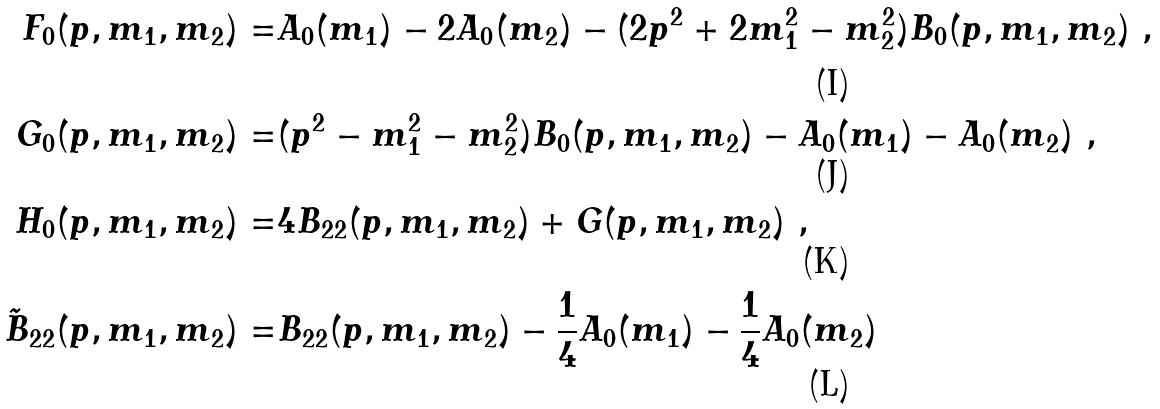Convert formula to latex. <formula><loc_0><loc_0><loc_500><loc_500>F _ { 0 } ( p , m _ { 1 } , m _ { 2 } ) = & A _ { 0 } ( m _ { 1 } ) - 2 A _ { 0 } ( m _ { 2 } ) - ( 2 p ^ { 2 } + 2 m ^ { 2 } _ { 1 } - m ^ { 2 } _ { 2 } ) B _ { 0 } ( p , m _ { 1 } , m _ { 2 } ) \ , \\ G _ { 0 } ( p , m _ { 1 } , m _ { 2 } ) = & ( p ^ { 2 } - m _ { 1 } ^ { 2 } - m _ { 2 } ^ { 2 } ) B _ { 0 } ( p , m _ { 1 } , m _ { 2 } ) - A _ { 0 } ( m _ { 1 } ) - A _ { 0 } ( m _ { 2 } ) \ , \\ H _ { 0 } ( p , m _ { 1 } , m _ { 2 } ) = & 4 B _ { 2 2 } ( p , m _ { 1 } , m _ { 2 } ) + G ( p , m _ { 1 } , m _ { 2 } ) \ , \\ \tilde { B } _ { 2 2 } ( p , m _ { 1 } , m _ { 2 } ) = & B _ { 2 2 } ( p , m _ { 1 } , m _ { 2 } ) - \frac { 1 } { 4 } A _ { 0 } ( m _ { 1 } ) - \frac { 1 } { 4 } A _ { 0 } ( m _ { 2 } )</formula> 